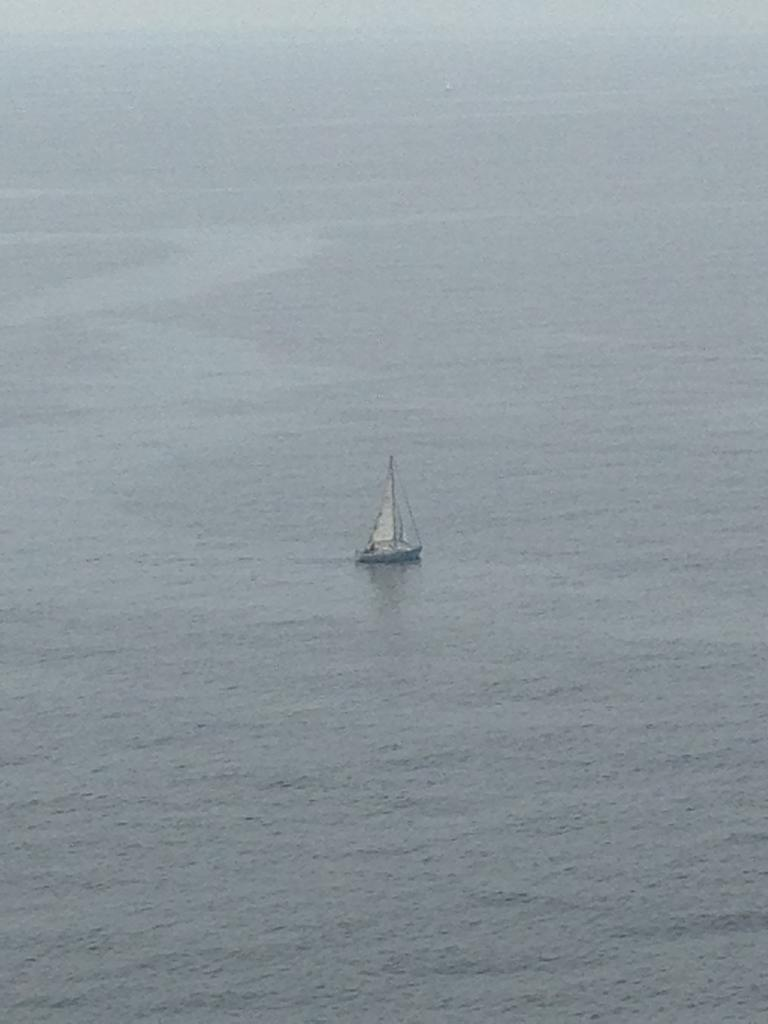What is the main subject of the image? The main subject of the image is a boat. Where is the boat located? The boat is on water. What type of flag is flying in the bedroom of the business in the image? There is: There is no mention of a flag, bedroom, or business in the image; it only features a boat on water. 